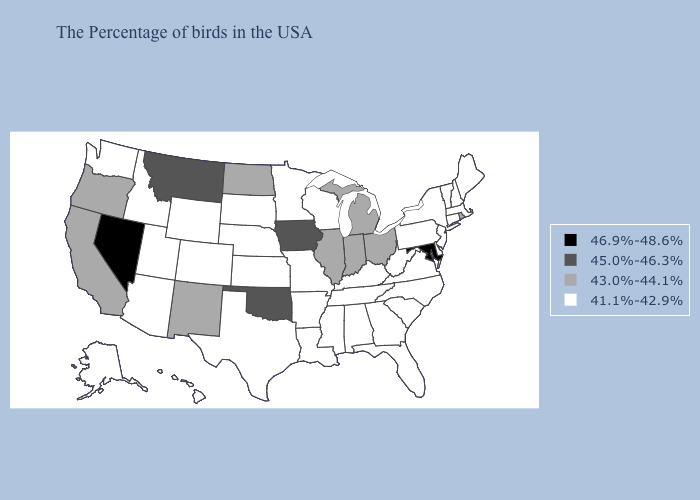Does Mississippi have the same value as Colorado?
Give a very brief answer. Yes. Does Michigan have the lowest value in the MidWest?
Concise answer only. No. Which states hav the highest value in the Northeast?
Quick response, please. Rhode Island. Which states have the lowest value in the Northeast?
Keep it brief. Maine, Massachusetts, New Hampshire, Vermont, Connecticut, New York, New Jersey, Pennsylvania. What is the highest value in states that border Alabama?
Quick response, please. 41.1%-42.9%. What is the lowest value in the USA?
Quick response, please. 41.1%-42.9%. What is the value of New Hampshire?
Keep it brief. 41.1%-42.9%. Among the states that border Nebraska , which have the lowest value?
Quick response, please. Missouri, Kansas, South Dakota, Wyoming, Colorado. Name the states that have a value in the range 43.0%-44.1%?
Short answer required. Rhode Island, Ohio, Michigan, Indiana, Illinois, North Dakota, New Mexico, California, Oregon. What is the value of Virginia?
Give a very brief answer. 41.1%-42.9%. Name the states that have a value in the range 46.9%-48.6%?
Quick response, please. Maryland, Nevada. What is the lowest value in the USA?
Short answer required. 41.1%-42.9%. Which states have the lowest value in the MidWest?
Keep it brief. Wisconsin, Missouri, Minnesota, Kansas, Nebraska, South Dakota. Does Maryland have the highest value in the USA?
Keep it brief. Yes. What is the value of Kentucky?
Give a very brief answer. 41.1%-42.9%. 